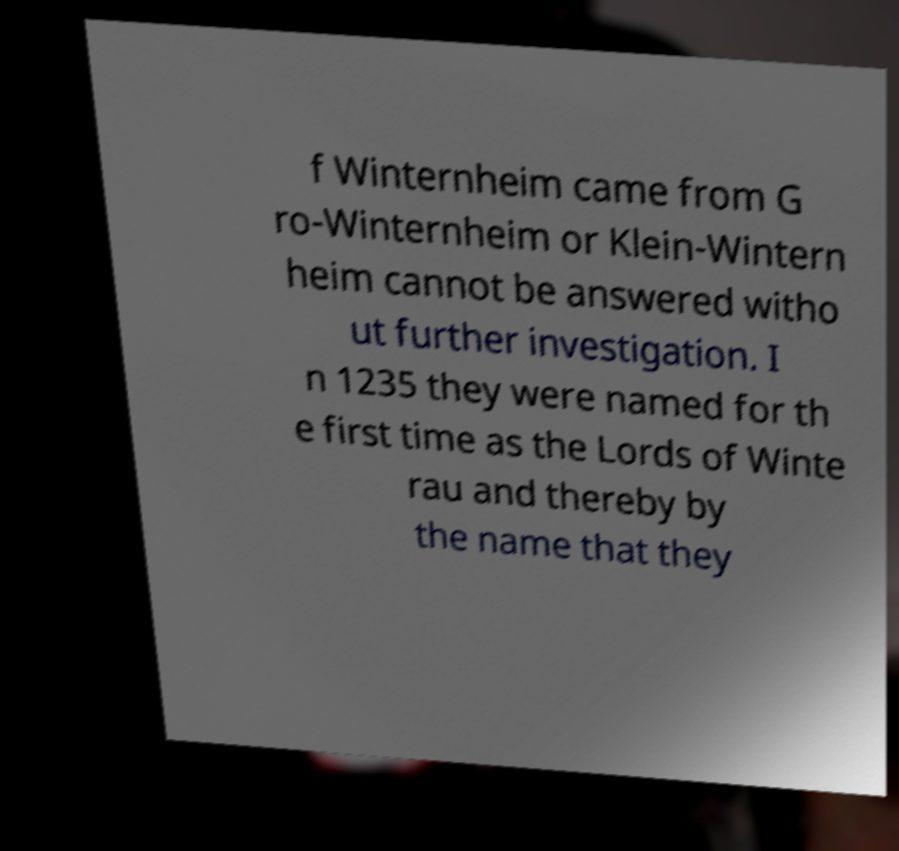I need the written content from this picture converted into text. Can you do that? f Winternheim came from G ro-Winternheim or Klein-Wintern heim cannot be answered witho ut further investigation. I n 1235 they were named for th e first time as the Lords of Winte rau and thereby by the name that they 